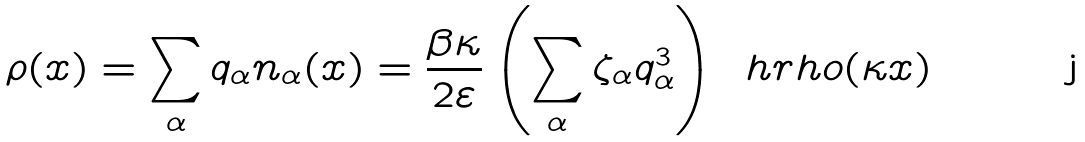Convert formula to latex. <formula><loc_0><loc_0><loc_500><loc_500>\rho ( x ) = \sum _ { \alpha } q _ { \alpha } n _ { \alpha } ( x ) = \frac { \beta \kappa } { 2 \varepsilon } \left ( \sum _ { \alpha } \zeta _ { \alpha } q _ { \alpha } ^ { 3 } \right ) \, \ h r h o ( \kappa x )</formula> 